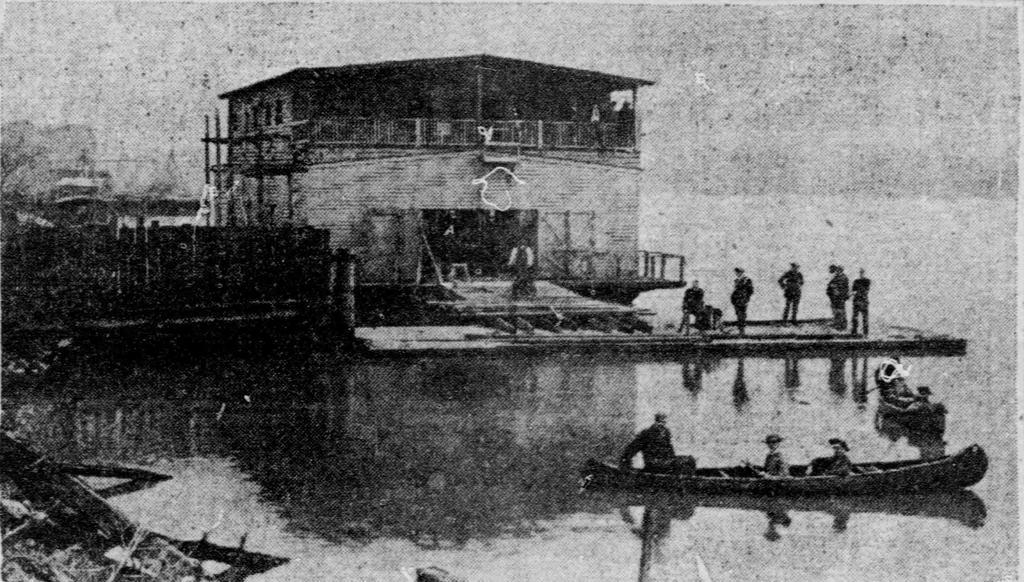What is in the water in the image? There is a boat in the water in the image. Who is in the boat? People are sitting in the boat. Are there any other people visible in the image? Yes, there are people standing near the boat. What can be seen in the background of the image? There is a fence and a wooden building in the image, and the sky is visible. What type of record is being played by the people in the boat? There is no record or music player visible in the image, so it cannot be determined if a record is being played. 